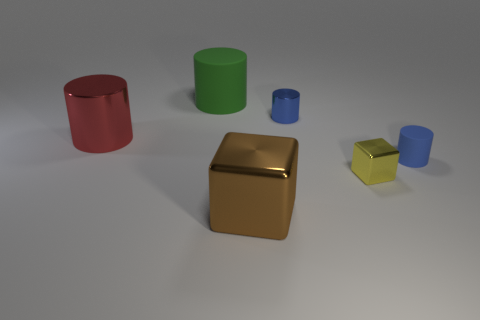Does the blue shiny cylinder have the same size as the rubber thing that is right of the large matte cylinder?
Your answer should be compact. Yes. What color is the metallic object that is both behind the tiny shiny block and to the right of the large green matte object?
Offer a terse response. Blue. How many other things are the same shape as the big green matte object?
Your answer should be very brief. 3. Does the big metal object to the left of the brown block have the same color as the tiny cylinder right of the small yellow metallic cube?
Keep it short and to the point. No. Do the shiny object that is on the left side of the big matte object and the rubber object behind the large metallic cylinder have the same size?
Keep it short and to the point. Yes. Are there any other things that are made of the same material as the large brown thing?
Your response must be concise. Yes. What material is the blue cylinder that is behind the matte cylinder that is in front of the metallic cylinder that is to the left of the green cylinder made of?
Ensure brevity in your answer.  Metal. Do the big green thing and the blue shiny thing have the same shape?
Make the answer very short. Yes. There is another big thing that is the same shape as the green thing; what is it made of?
Provide a succinct answer. Metal. How many other metal cubes have the same color as the tiny shiny block?
Ensure brevity in your answer.  0. 